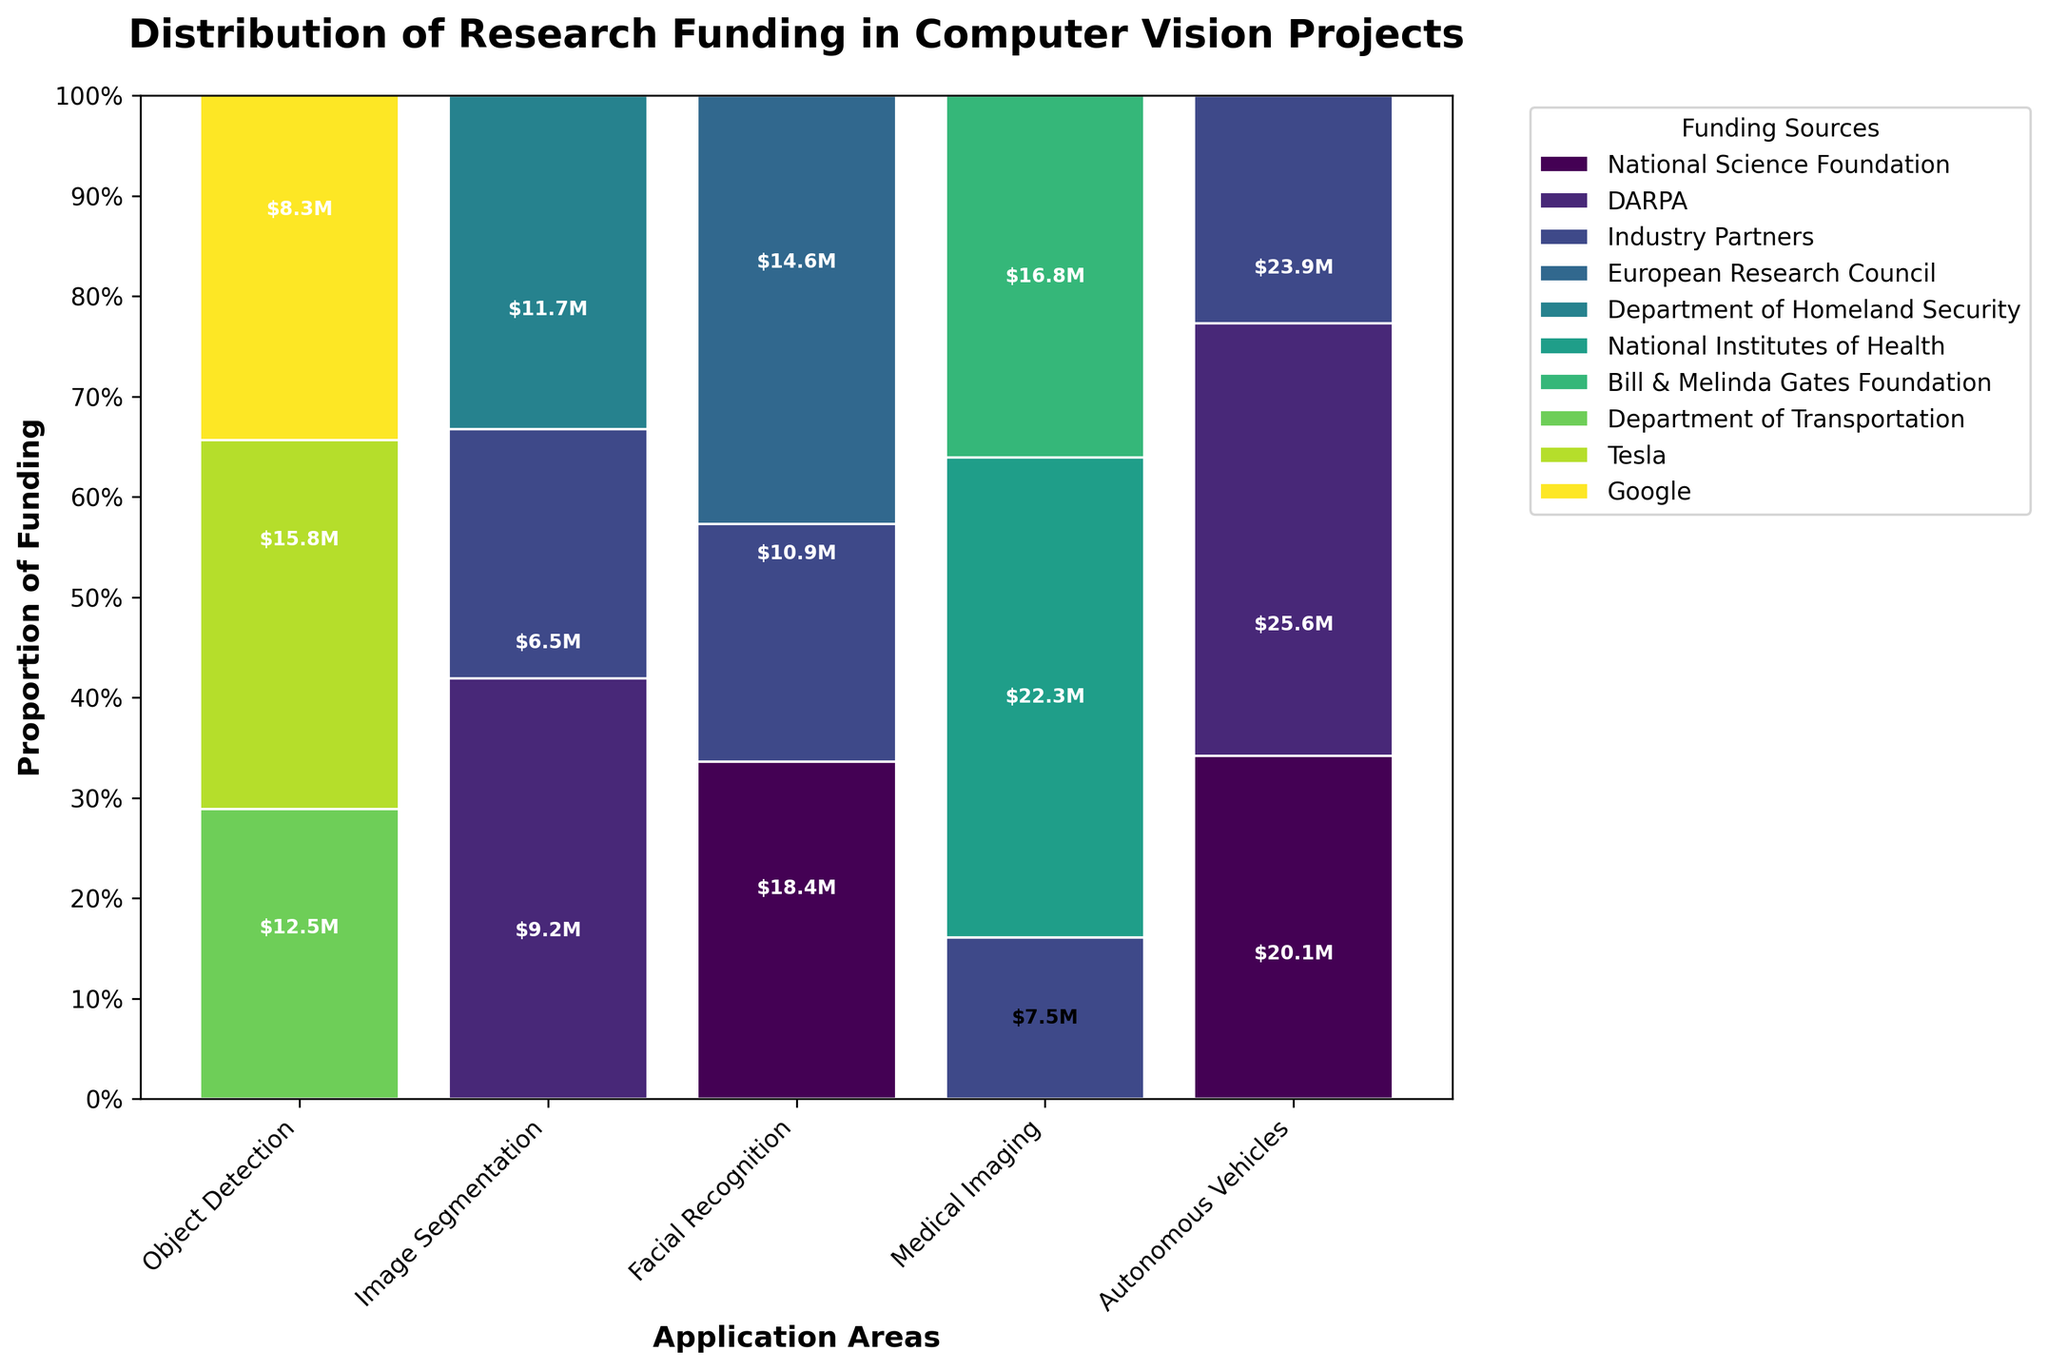What is the title of the plot? The title of the plot is usually located at the top of the figure, which provides an overview of what the chart represents.
Answer: Distribution of Research Funding in Computer Vision Projects How many application areas are there? Count the number of unique categories along the x-axis, representing the different application areas.
Answer: 5 Which funding source has the smallest proportion of funding in Object Detection? Observe the segments within the 'Object Detection' bar and identify the smallest segment based on its height.
Answer: Industry Partners What is the total amount of funding for Facial Recognition? Sum the amounts indicated within the different segments of the 'Facial Recognition' bar: DARPA, Department of Homeland Security, and Industry Partners. This totals $18.4M + $14.6M + $10.9M.
Answer: $43.9M Which application area has the highest total funding? Compare the total heights of the bars representing different application areas; the tallest bar indicates the area with the highest total funding.
Answer: Autonomous Vehicles How much more funding does DARPA provide for Object Detection than Facial Recognition? Identify the values labeled within the DARPA segments for both 'Object Detection' and 'Facial Recognition' and subtract the latter from the former: $15.8M - $18.4M.
Answer: -$2.6M What proportion of funding for Medical Imaging comes from the Bill & Melinda Gates Foundation? Find the height of the Bill & Melinda Gates Foundation segment within the 'Medical Imaging' bar and compare it to the total height, which represents the total funding for that area.
Answer: 0.43 (or 43%) Which funding source provides the highest proportion of funding for Autonomous Vehicles? Compare the heights of the segments within the 'Autonomous Vehicles' bar, representing different funding sources, to identify which one is the largest.
Answer: Tesla How many funding sources are there in total? Count the number of unique categories used to color the segments within the bars, each representing a different funding source.
Answer: 10 Which application area receives funding from the fewest number of sources? Count the number of distinct segments within each bar and identify the one with the fewest segments indicating distinct funding sources.
Answer: Autonomous Vehicles 